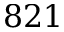<formula> <loc_0><loc_0><loc_500><loc_500>8 2 1</formula> 